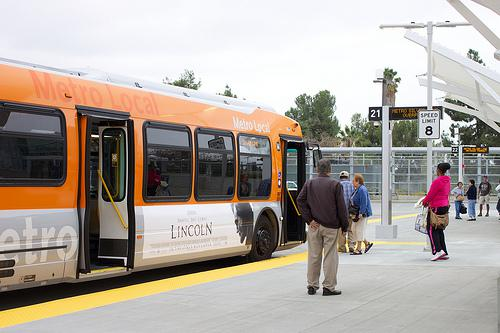Question: what is the speed limit?
Choices:
A. 8.
B. 35.
C. 25.
D. 75.
Answer with the letter. Answer: A Question: where is the speed limit sign?
Choices:
A. On a post.
B. Side of road.
C. On railing.
D. Above the street.
Answer with the letter. Answer: A Question: why is there a bus?
Choices:
A. Take kids to school.
B. For the city people.
C. To bring people from one place to another.
D. To transport people.
Answer with the letter. Answer: D Question: who has a pink sweatshirt?
Choices:
A. The baby.
B. A little girl.
C. The woman.
D. The dog.
Answer with the letter. Answer: C Question: what color is the bus?
Choices:
A. Yellow.
B. White.
C. Orange.
D. Gold.
Answer with the letter. Answer: C 